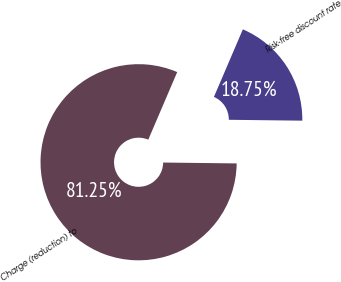Convert chart to OTSL. <chart><loc_0><loc_0><loc_500><loc_500><pie_chart><fcel>Charge (reduction) to<fcel>Risk-free discount rate<nl><fcel>81.25%<fcel>18.75%<nl></chart> 